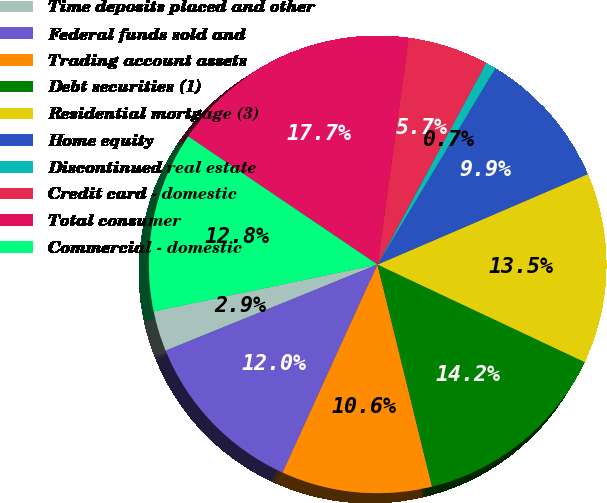Convert chart to OTSL. <chart><loc_0><loc_0><loc_500><loc_500><pie_chart><fcel>Time deposits placed and other<fcel>Federal funds sold and<fcel>Trading account assets<fcel>Debt securities (1)<fcel>Residential mortgage (3)<fcel>Home equity<fcel>Discontinued real estate<fcel>Credit card - domestic<fcel>Total consumer<fcel>Commercial - domestic<nl><fcel>2.86%<fcel>12.05%<fcel>10.64%<fcel>14.17%<fcel>13.47%<fcel>9.93%<fcel>0.74%<fcel>5.69%<fcel>17.71%<fcel>12.76%<nl></chart> 